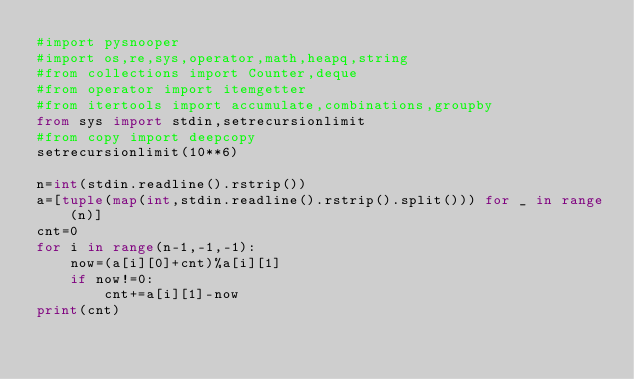Convert code to text. <code><loc_0><loc_0><loc_500><loc_500><_Python_>#import pysnooper
#import os,re,sys,operator,math,heapq,string
#from collections import Counter,deque
#from operator import itemgetter
#from itertools import accumulate,combinations,groupby
from sys import stdin,setrecursionlimit
#from copy import deepcopy
setrecursionlimit(10**6)

n=int(stdin.readline().rstrip())
a=[tuple(map(int,stdin.readline().rstrip().split())) for _ in range(n)]
cnt=0
for i in range(n-1,-1,-1):
    now=(a[i][0]+cnt)%a[i][1]
    if now!=0:
        cnt+=a[i][1]-now
print(cnt)</code> 